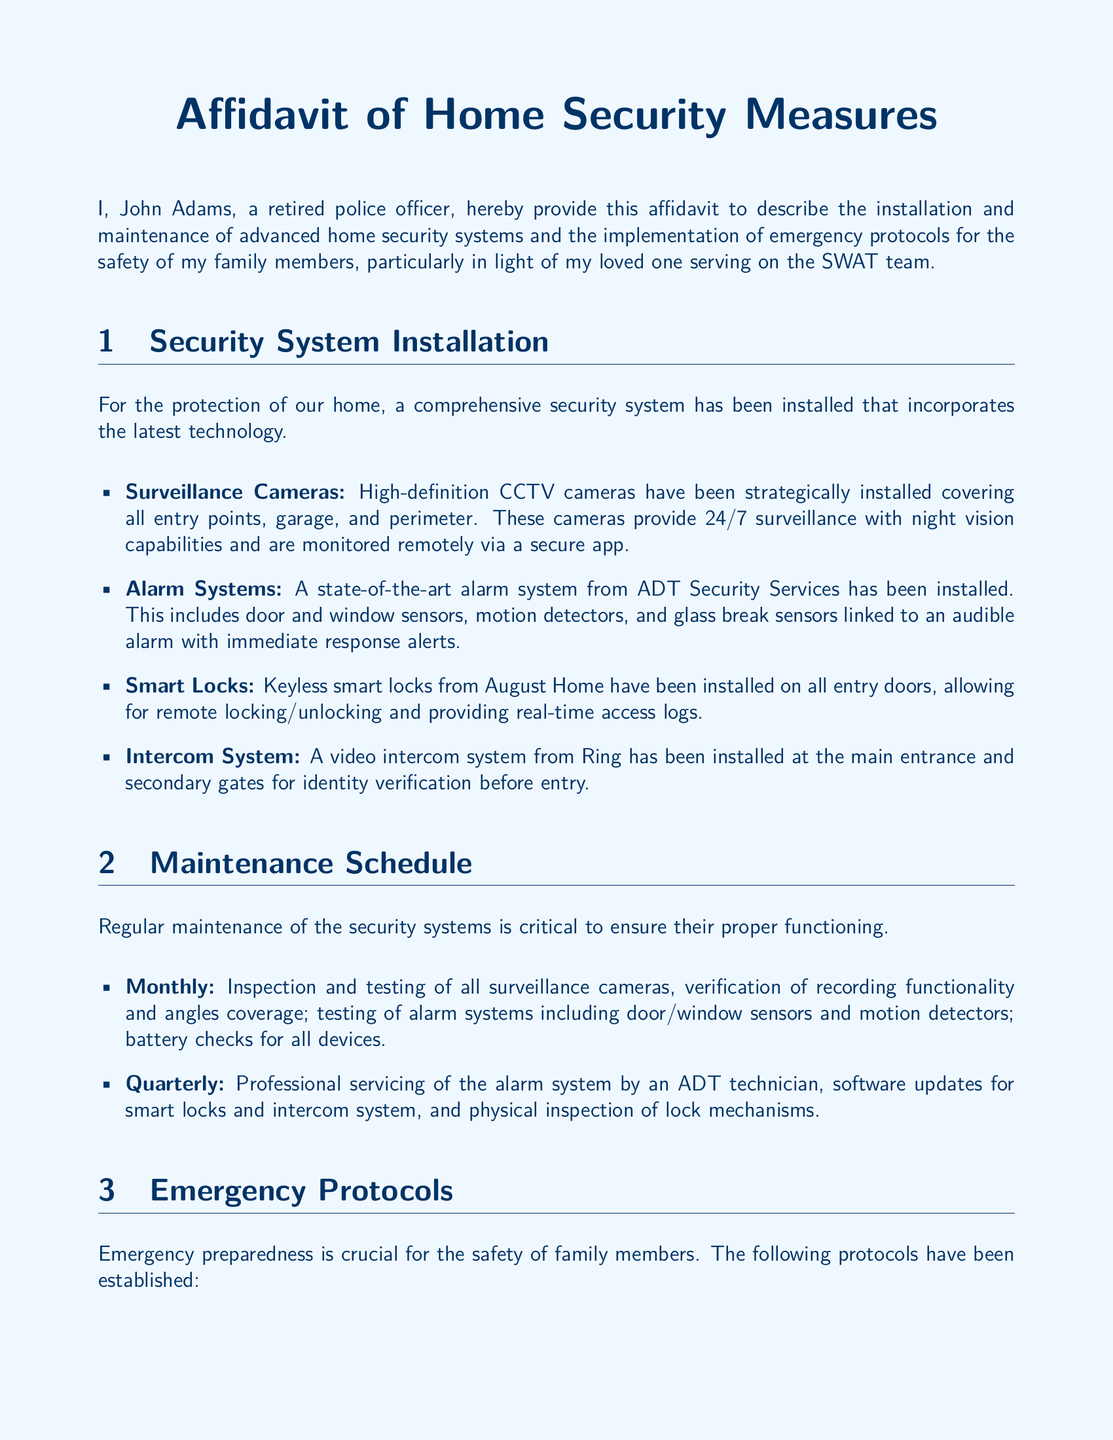What is the name of the individual providing the affidavit? The name of the individual is stated in the introduction of the document as John Adams.
Answer: John Adams What type of alarm system has been installed? The specific brand and type of alarm system mentioned in the document is from ADT Security Services, including various sensors.
Answer: ADT Security Services How often is professional servicing of the alarm system conducted? The document indicates that professional servicing occurs every three months, which is quarterly.
Answer: Quarterly What type of cameras have been installed? The document specifies that high-definition CCTV cameras have been installed with certain capabilities.
Answer: High-definition CCTV cameras What is posted near all telephones? The document mentions that an updated list of emergency contacts is posted near all telephones.
Answer: Emergency contacts What measures are taken to ensure family members know the emergency protocols? The document includes a practice measure, which involves conducting bi-annual emergency drills to familiarize family members with protocols.
Answer: Routine drills How many entry points are monitored by the security system? The document does not specify the exact number but indicates that all entry points are included in the coverage.
Answer: All entry points What is the purpose of panic buttons installed in the home? The document states that pressing the panic buttons alerts local police and triggers the alarm system.
Answer: Alert police and trigger alarm What is the daily maintenance frequency for inspections? The document clearly states that inspections are conducted monthly to ensure all systems are functioning.
Answer: Monthly 